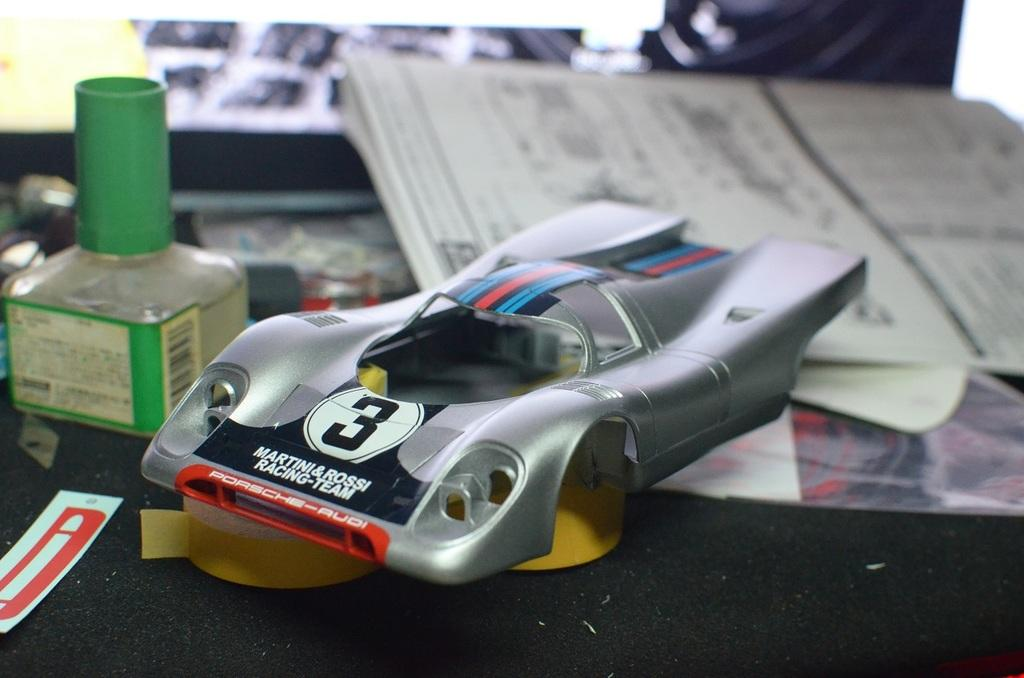What type of objects can be seen in the image? There are books, papers, toys, plasters, and a green bottle in the image. What might the books and papers be related to? The books and papers might be related to studying or working. What type of toys are present in the image? The toys in the image are not specified, but they are present. What might the plasters be used for? The plasters might be used for first aid or treating minor injuries. What type of steel is visible in the image? There is no steel present in the image. Can you see an oven in the image? There is no oven present in the image. Is there a boy visible in the image? There is no boy present in the image. 